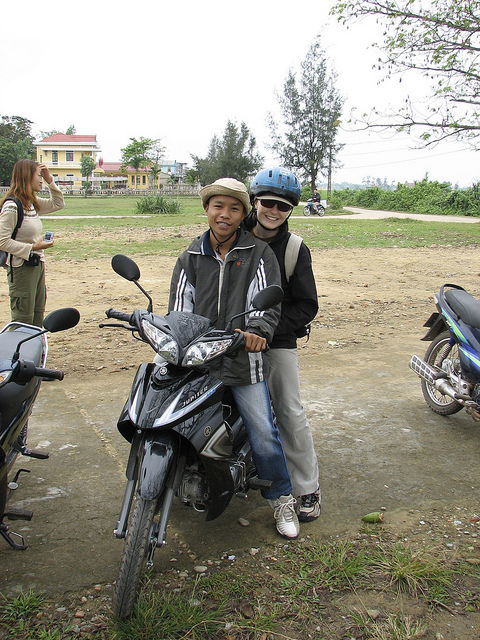<image>How long have the people been riding the bike? It is uncertain how long the people have been riding the bike. How long have the people been riding the bike? I don't know how long the people have been riding the bike. It could be a few hours, a short time, or all day. 